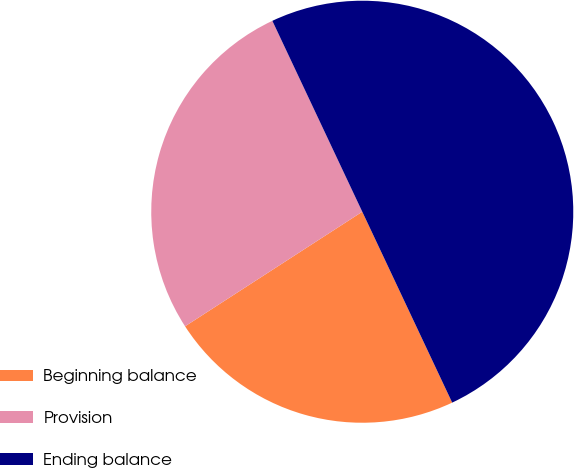Convert chart to OTSL. <chart><loc_0><loc_0><loc_500><loc_500><pie_chart><fcel>Beginning balance<fcel>Provision<fcel>Ending balance<nl><fcel>22.87%<fcel>27.13%<fcel>50.0%<nl></chart> 